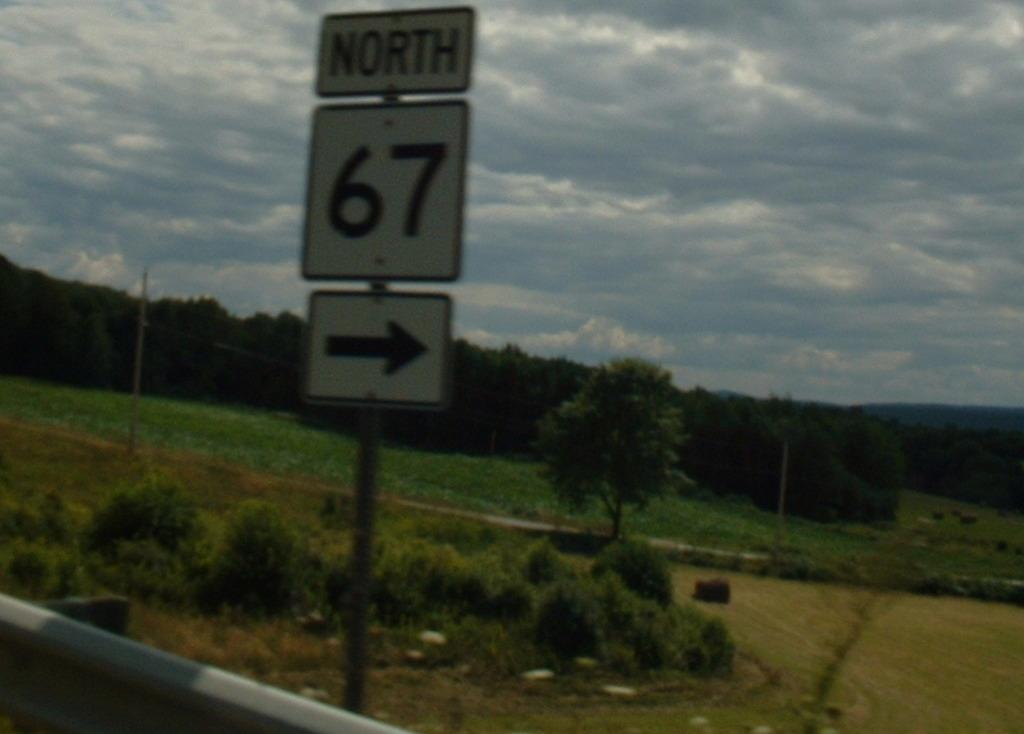What is the number on the sign?
Keep it short and to the point. 67. What direction is it?
Offer a very short reply. North. 